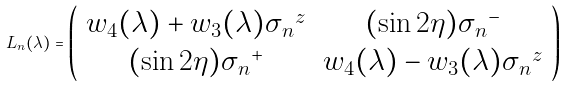Convert formula to latex. <formula><loc_0><loc_0><loc_500><loc_500>L _ { n } ( \lambda ) = \left ( \begin{array} { c c } w _ { 4 } ( \lambda ) + w _ { 3 } ( \lambda ) { \sigma _ { n } } ^ { z } & ( \sin 2 \eta ) { \sigma _ { n } } ^ { - } \\ ( \sin 2 \eta ) { \sigma _ { n } } ^ { + } & w _ { 4 } ( \lambda ) - w _ { 3 } ( \lambda ) { \sigma _ { n } } ^ { z } \end{array} \right )</formula> 